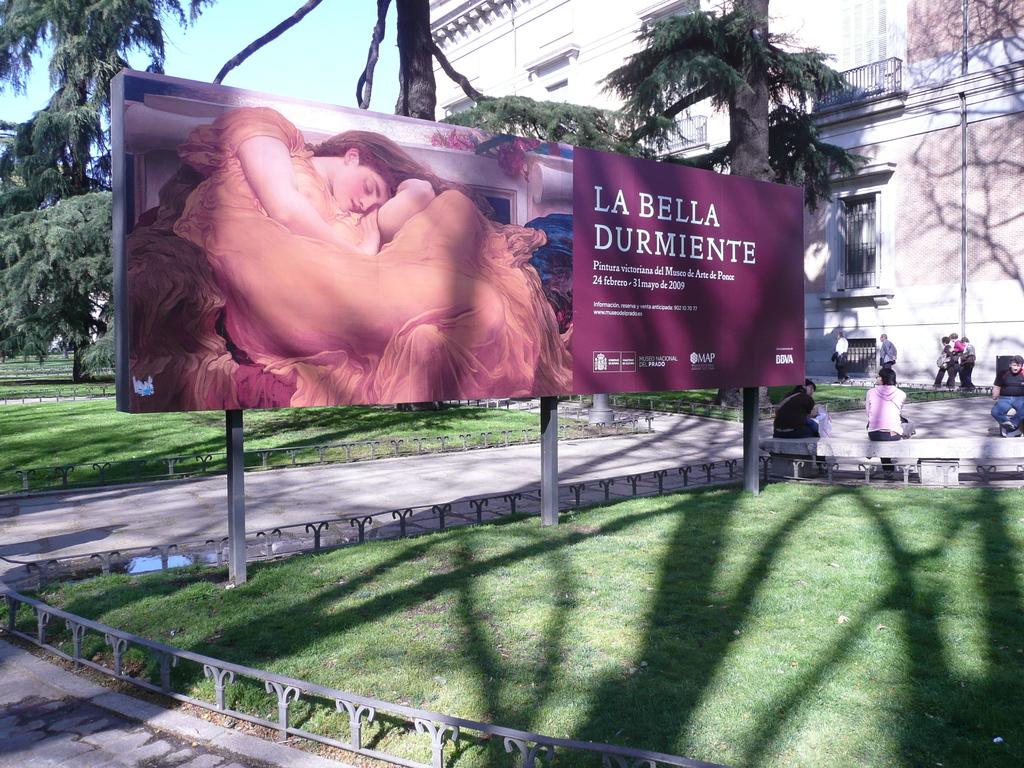What is on the billboard?
Your answer should be very brief. La bella durmiente. 